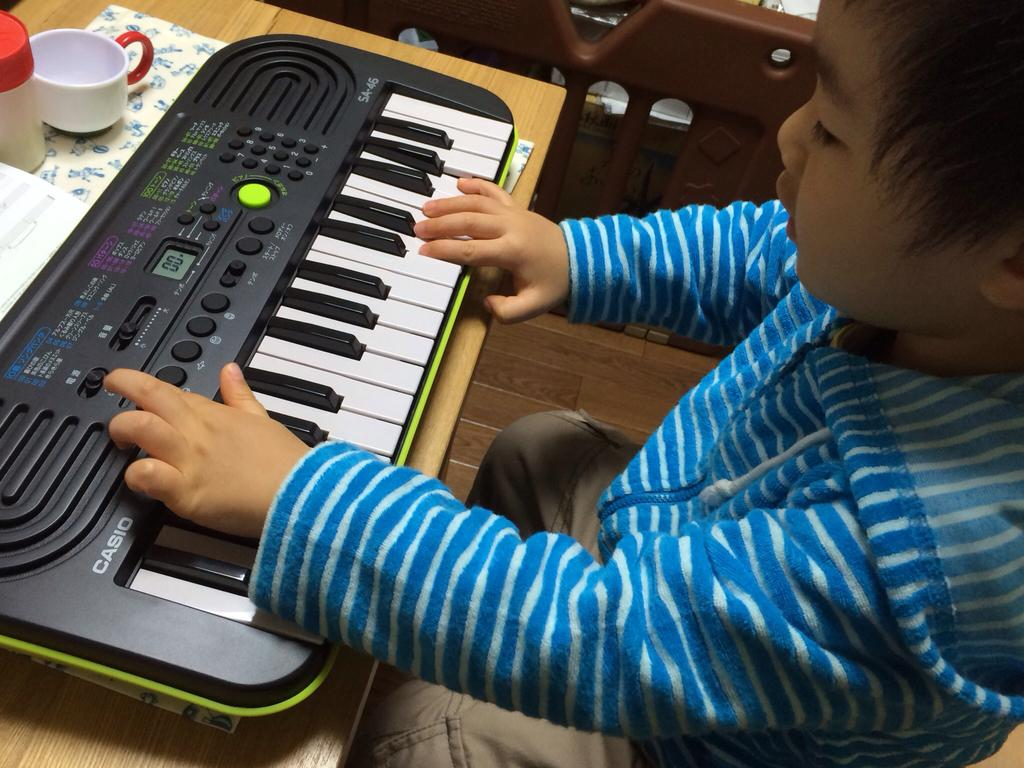What is the main subject of the image? The main subject of the image is a kid. What is the kid wearing? The kid is wearing a blue shirt. What activity is the kid engaged in? The kid is playing a piano. What brand is the piano? The piano is named CASIO. What objects can be seen on the table in the background? There is a cup and a container on the table in the background. What color is the plate in the image? There is a brown color plate in the image. How many trains and boats are visible in the image? There are no trains or boats present in the image. 